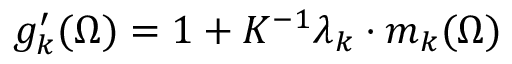<formula> <loc_0><loc_0><loc_500><loc_500>g _ { k } ^ { \prime } ( \Omega ) = 1 + K ^ { - 1 } \lambda _ { k } \cdot m _ { k } ( \Omega )</formula> 